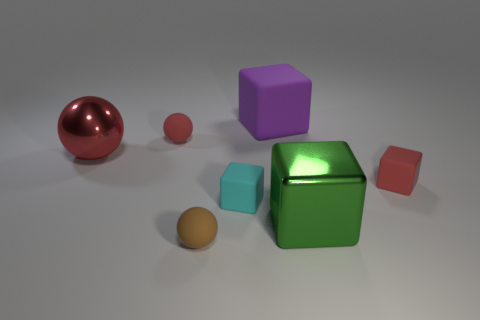There is a large purple rubber thing; is it the same shape as the big metallic object right of the tiny brown matte ball?
Make the answer very short. Yes. How many objects are either large metallic objects on the left side of the brown matte object or tiny cyan shiny blocks?
Offer a terse response. 1. Is the purple thing made of the same material as the tiny ball behind the tiny red matte block?
Provide a short and direct response. Yes. What shape is the shiny thing in front of the large red thing in front of the large matte thing?
Make the answer very short. Cube. Does the metallic ball have the same color as the rubber object right of the big purple object?
Make the answer very short. Yes. The cyan object has what shape?
Keep it short and to the point. Cube. How big is the cube that is behind the small red thing left of the small cyan object?
Your response must be concise. Large. Are there an equal number of shiny things that are in front of the tiny cyan matte cube and small balls behind the tiny red rubber cube?
Keep it short and to the point. Yes. There is a red thing that is both right of the red metallic ball and to the left of the brown matte ball; what material is it?
Your response must be concise. Rubber. There is a cyan matte thing; is its size the same as the brown rubber thing on the left side of the big purple thing?
Provide a short and direct response. Yes. 